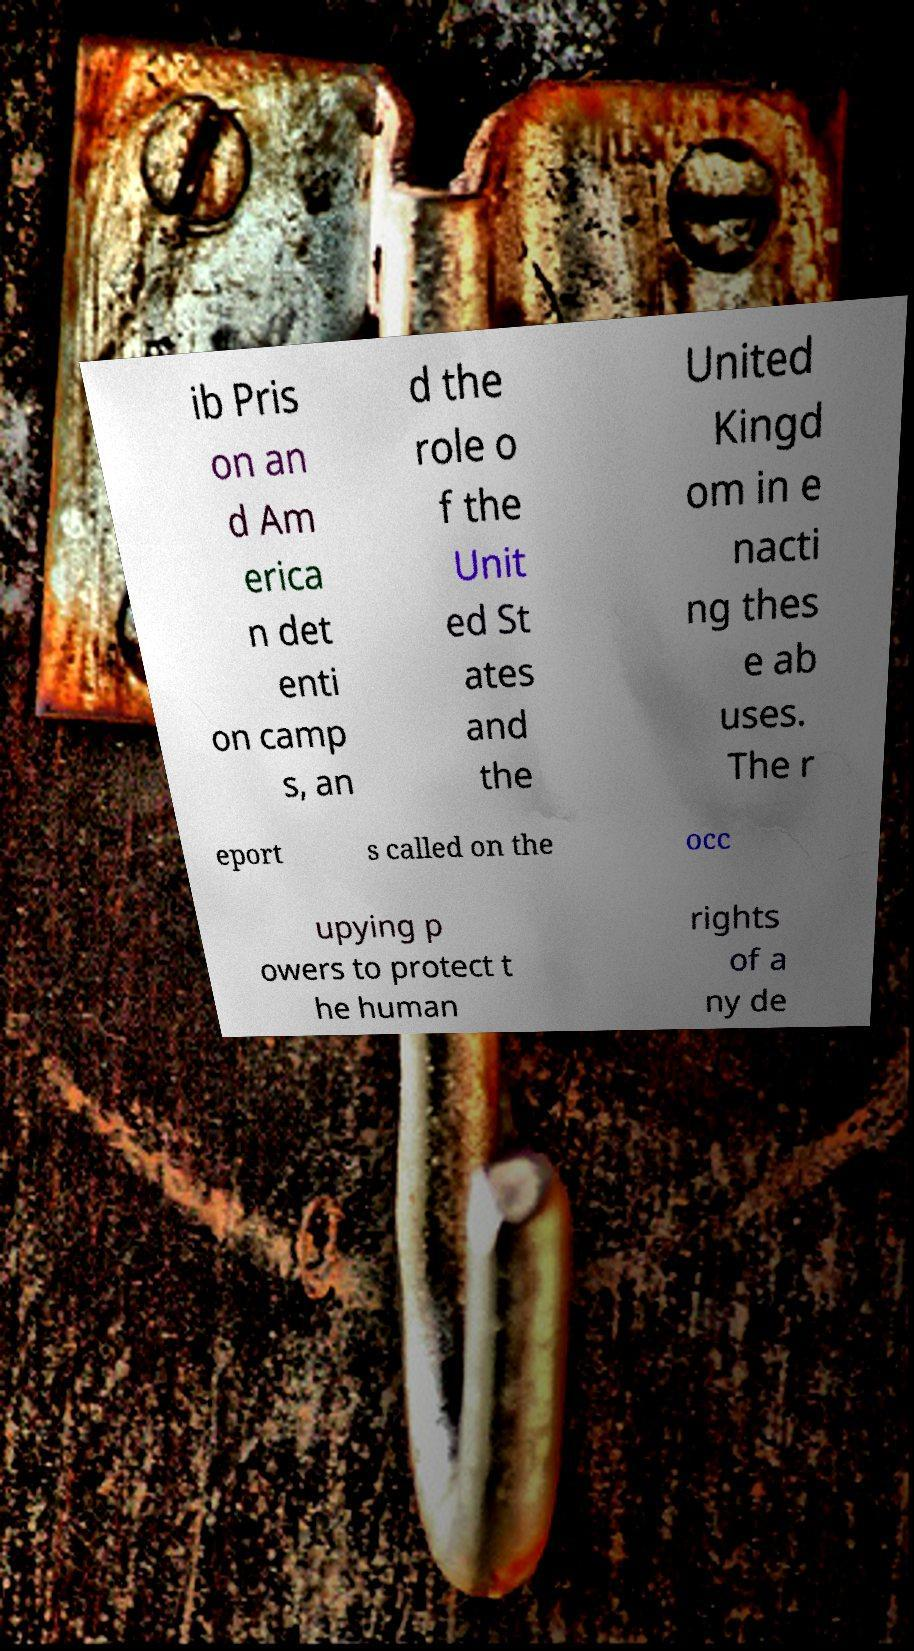Could you extract and type out the text from this image? ib Pris on an d Am erica n det enti on camp s, an d the role o f the Unit ed St ates and the United Kingd om in e nacti ng thes e ab uses. The r eport s called on the occ upying p owers to protect t he human rights of a ny de 